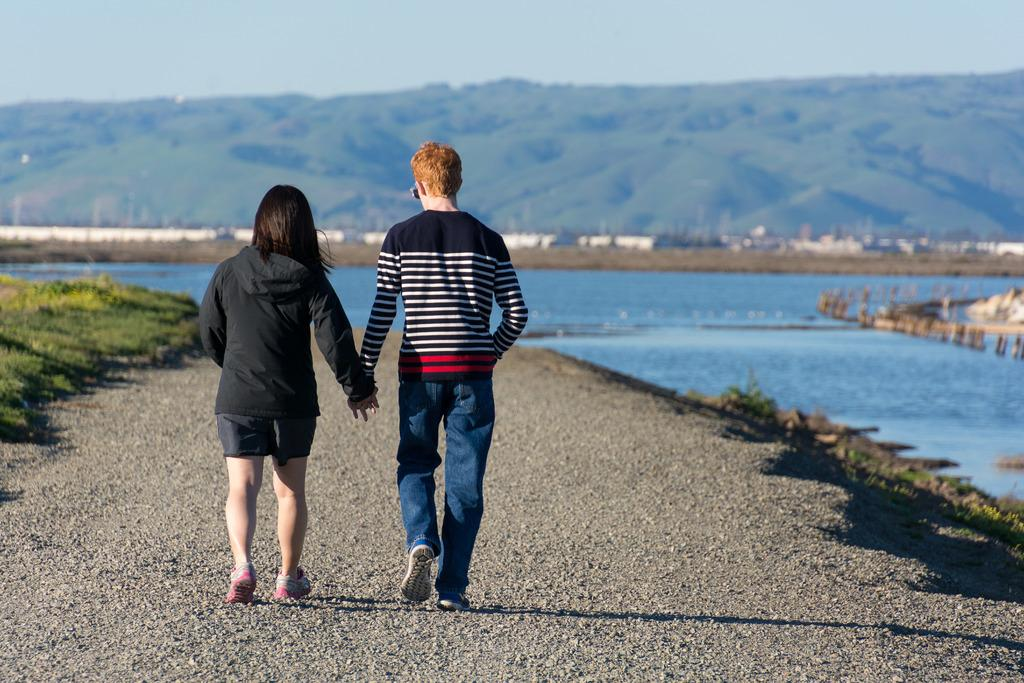What are the two people in the image doing? The two people in the image are walking. What type of terrain can be seen in the image? There is grass, water, hills, and trees visible in the image. What part of the natural environment is visible in the image? The sky is visible in the image. Where is the cap placed in the image? There is no cap present in the image. What type of icicle can be seen hanging from the trees in the image? There are no icicles present in the image, as it appears to be a warm and grassy environment. 